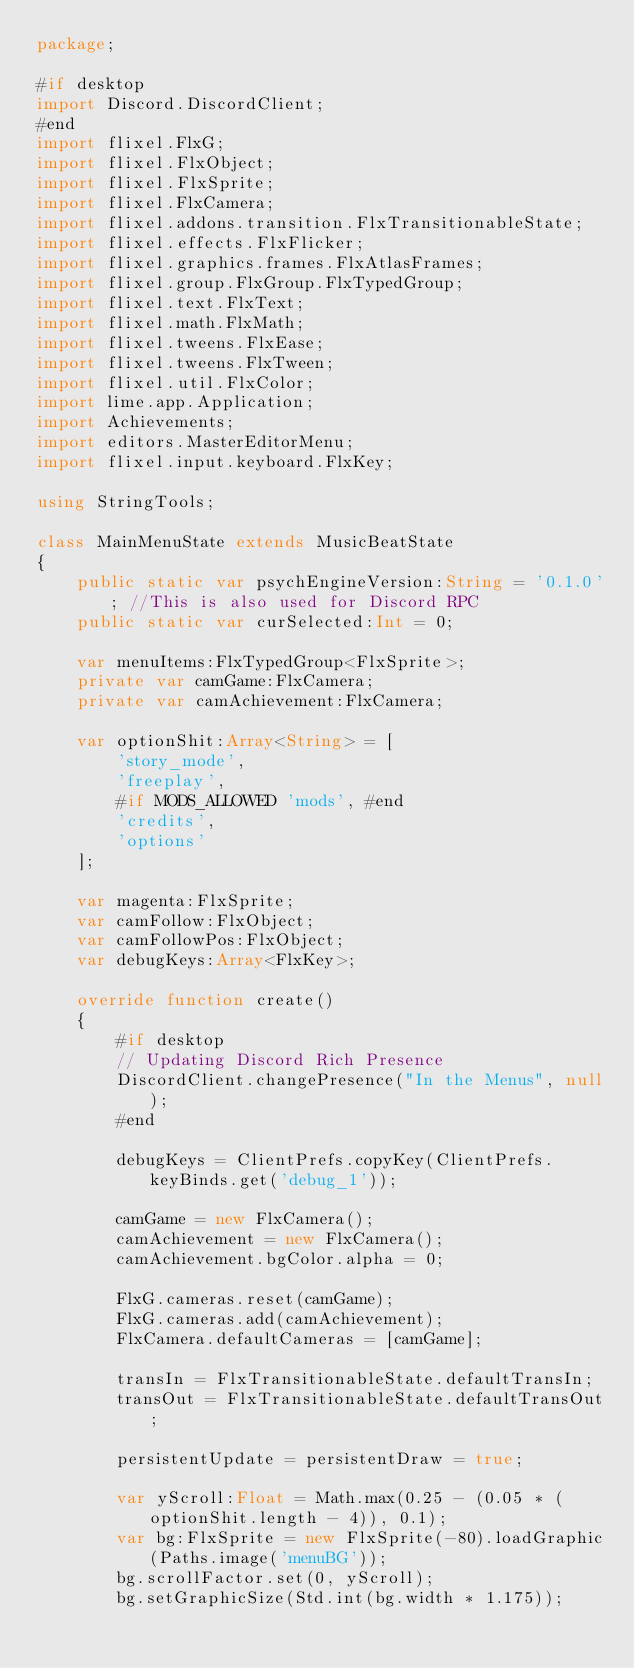<code> <loc_0><loc_0><loc_500><loc_500><_Haxe_>package;

#if desktop
import Discord.DiscordClient;
#end
import flixel.FlxG;
import flixel.FlxObject;
import flixel.FlxSprite;
import flixel.FlxCamera;
import flixel.addons.transition.FlxTransitionableState;
import flixel.effects.FlxFlicker;
import flixel.graphics.frames.FlxAtlasFrames;
import flixel.group.FlxGroup.FlxTypedGroup;
import flixel.text.FlxText;
import flixel.math.FlxMath;
import flixel.tweens.FlxEase;
import flixel.tweens.FlxTween;
import flixel.util.FlxColor;
import lime.app.Application;
import Achievements;
import editors.MasterEditorMenu;
import flixel.input.keyboard.FlxKey;

using StringTools;

class MainMenuState extends MusicBeatState
{
	public static var psychEngineVersion:String = '0.1.0'; //This is also used for Discord RPC
	public static var curSelected:Int = 0;

	var menuItems:FlxTypedGroup<FlxSprite>;
	private var camGame:FlxCamera;
	private var camAchievement:FlxCamera;
	
	var optionShit:Array<String> = [
		'story_mode',
		'freeplay',
		#if MODS_ALLOWED 'mods', #end
		'credits',
		'options'
	];

	var magenta:FlxSprite;
	var camFollow:FlxObject;
	var camFollowPos:FlxObject;
	var debugKeys:Array<FlxKey>;

	override function create()
	{
		#if desktop
		// Updating Discord Rich Presence
		DiscordClient.changePresence("In the Menus", null);
		#end

		debugKeys = ClientPrefs.copyKey(ClientPrefs.keyBinds.get('debug_1'));

		camGame = new FlxCamera();
		camAchievement = new FlxCamera();
		camAchievement.bgColor.alpha = 0;

		FlxG.cameras.reset(camGame);
		FlxG.cameras.add(camAchievement);
		FlxCamera.defaultCameras = [camGame];

		transIn = FlxTransitionableState.defaultTransIn;
		transOut = FlxTransitionableState.defaultTransOut;

		persistentUpdate = persistentDraw = true;

		var yScroll:Float = Math.max(0.25 - (0.05 * (optionShit.length - 4)), 0.1);
		var bg:FlxSprite = new FlxSprite(-80).loadGraphic(Paths.image('menuBG'));
		bg.scrollFactor.set(0, yScroll);
		bg.setGraphicSize(Std.int(bg.width * 1.175));</code> 